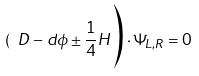Convert formula to latex. <formula><loc_0><loc_0><loc_500><loc_500>( \ D - d \phi \pm \frac { 1 } { 4 } H \Big ) \cdot \Psi _ { L , R } = 0</formula> 